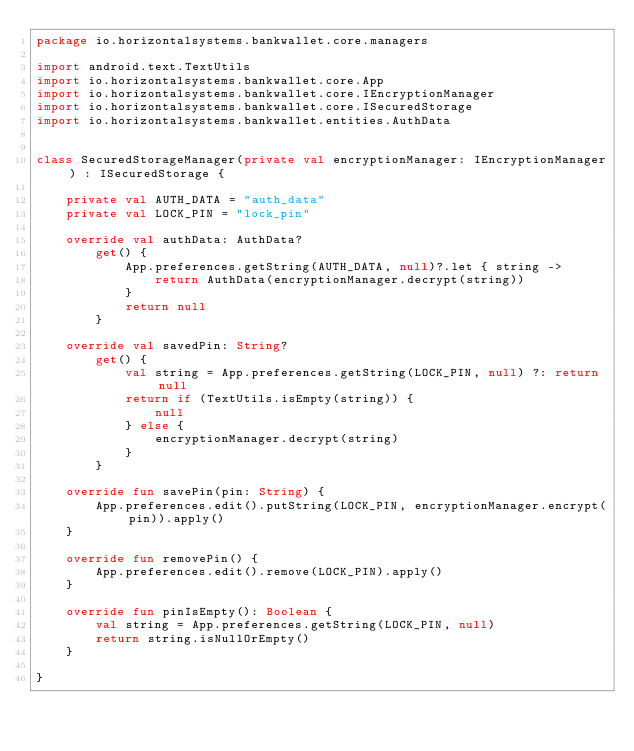Convert code to text. <code><loc_0><loc_0><loc_500><loc_500><_Kotlin_>package io.horizontalsystems.bankwallet.core.managers

import android.text.TextUtils
import io.horizontalsystems.bankwallet.core.App
import io.horizontalsystems.bankwallet.core.IEncryptionManager
import io.horizontalsystems.bankwallet.core.ISecuredStorage
import io.horizontalsystems.bankwallet.entities.AuthData


class SecuredStorageManager(private val encryptionManager: IEncryptionManager) : ISecuredStorage {

    private val AUTH_DATA = "auth_data"
    private val LOCK_PIN = "lock_pin"

    override val authData: AuthData?
        get() {
            App.preferences.getString(AUTH_DATA, null)?.let { string ->
                return AuthData(encryptionManager.decrypt(string))
            }
            return null
        }

    override val savedPin: String?
        get() {
            val string = App.preferences.getString(LOCK_PIN, null) ?: return null
            return if (TextUtils.isEmpty(string)) {
                null
            } else {
                encryptionManager.decrypt(string)
            }
        }

    override fun savePin(pin: String) {
        App.preferences.edit().putString(LOCK_PIN, encryptionManager.encrypt(pin)).apply()
    }

    override fun removePin() {
        App.preferences.edit().remove(LOCK_PIN).apply()
    }

    override fun pinIsEmpty(): Boolean {
        val string = App.preferences.getString(LOCK_PIN, null)
        return string.isNullOrEmpty()
    }

}
</code> 